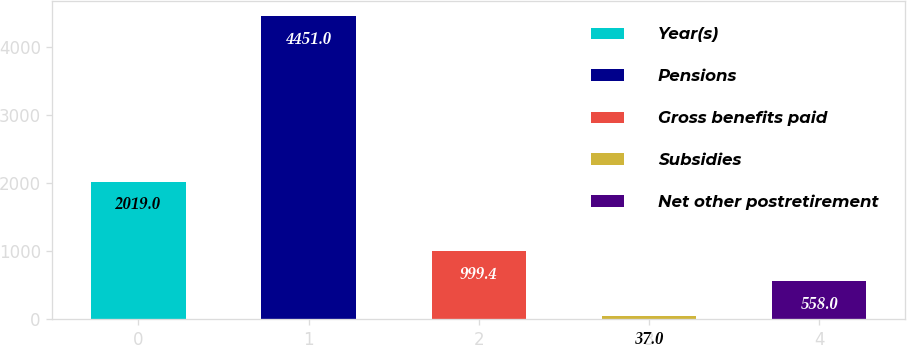<chart> <loc_0><loc_0><loc_500><loc_500><bar_chart><fcel>Year(s)<fcel>Pensions<fcel>Gross benefits paid<fcel>Subsidies<fcel>Net other postretirement<nl><fcel>2019<fcel>4451<fcel>999.4<fcel>37<fcel>558<nl></chart> 